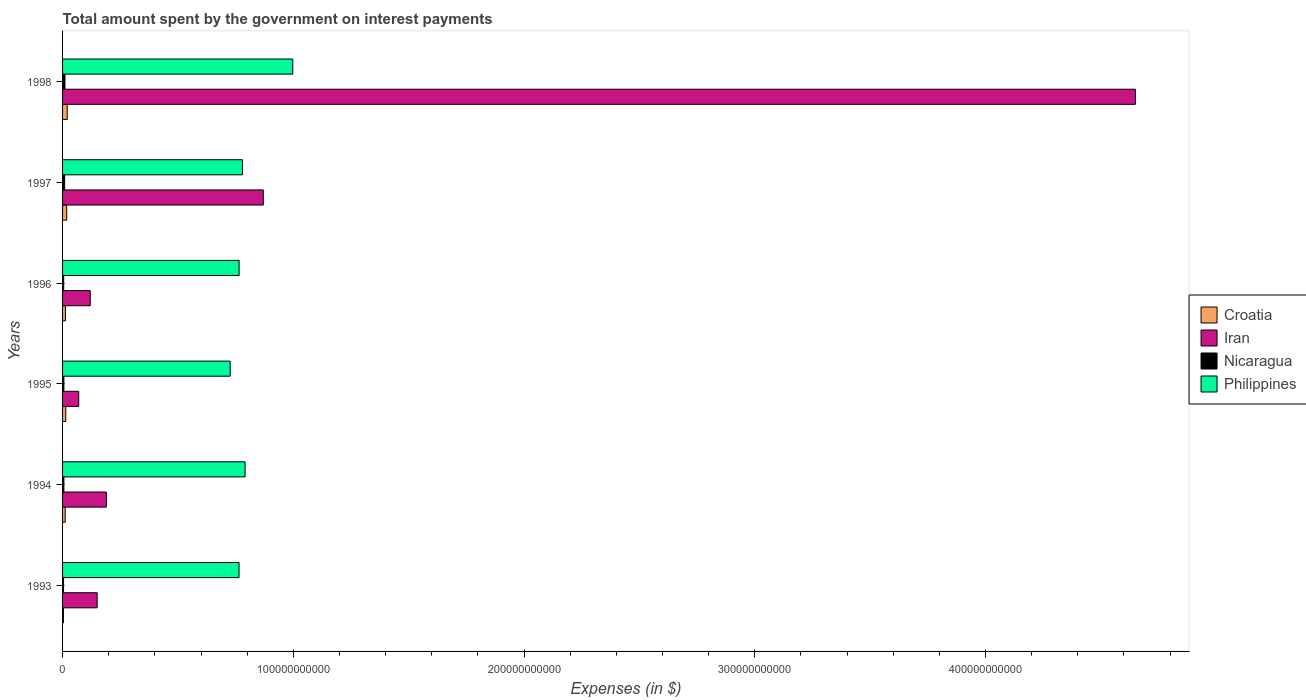How many different coloured bars are there?
Provide a short and direct response. 4. How many groups of bars are there?
Provide a succinct answer. 6. How many bars are there on the 5th tick from the top?
Offer a terse response. 4. How many bars are there on the 1st tick from the bottom?
Your response must be concise. 4. What is the label of the 6th group of bars from the top?
Your answer should be very brief. 1993. In how many cases, is the number of bars for a given year not equal to the number of legend labels?
Give a very brief answer. 0. What is the amount spent on interest payments by the government in Nicaragua in 1994?
Make the answer very short. 5.79e+08. Across all years, what is the maximum amount spent on interest payments by the government in Croatia?
Provide a succinct answer. 2.03e+09. Across all years, what is the minimum amount spent on interest payments by the government in Croatia?
Provide a short and direct response. 3.82e+08. In which year was the amount spent on interest payments by the government in Iran maximum?
Your answer should be very brief. 1998. In which year was the amount spent on interest payments by the government in Iran minimum?
Make the answer very short. 1995. What is the total amount spent on interest payments by the government in Iran in the graph?
Your answer should be very brief. 6.05e+11. What is the difference between the amount spent on interest payments by the government in Iran in 1995 and that in 1996?
Give a very brief answer. -5.00e+09. What is the difference between the amount spent on interest payments by the government in Croatia in 1996 and the amount spent on interest payments by the government in Iran in 1998?
Your answer should be very brief. -4.64e+11. What is the average amount spent on interest payments by the government in Philippines per year?
Your answer should be very brief. 8.04e+1. In the year 1994, what is the difference between the amount spent on interest payments by the government in Nicaragua and amount spent on interest payments by the government in Philippines?
Offer a terse response. -7.85e+1. What is the ratio of the amount spent on interest payments by the government in Croatia in 1994 to that in 1996?
Ensure brevity in your answer.  0.92. What is the difference between the highest and the second highest amount spent on interest payments by the government in Nicaragua?
Give a very brief answer. 1.47e+08. What is the difference between the highest and the lowest amount spent on interest payments by the government in Croatia?
Offer a terse response. 1.64e+09. Is the sum of the amount spent on interest payments by the government in Croatia in 1994 and 1997 greater than the maximum amount spent on interest payments by the government in Philippines across all years?
Offer a very short reply. No. Is it the case that in every year, the sum of the amount spent on interest payments by the government in Croatia and amount spent on interest payments by the government in Iran is greater than the sum of amount spent on interest payments by the government in Nicaragua and amount spent on interest payments by the government in Philippines?
Keep it short and to the point. No. What does the 2nd bar from the top in 1997 represents?
Your response must be concise. Nicaragua. What does the 1st bar from the bottom in 1993 represents?
Offer a very short reply. Croatia. Is it the case that in every year, the sum of the amount spent on interest payments by the government in Philippines and amount spent on interest payments by the government in Nicaragua is greater than the amount spent on interest payments by the government in Iran?
Your response must be concise. No. What is the difference between two consecutive major ticks on the X-axis?
Your answer should be very brief. 1.00e+11. Does the graph contain any zero values?
Offer a very short reply. No. How are the legend labels stacked?
Your response must be concise. Vertical. What is the title of the graph?
Ensure brevity in your answer.  Total amount spent by the government on interest payments. What is the label or title of the X-axis?
Give a very brief answer. Expenses (in $). What is the label or title of the Y-axis?
Your answer should be compact. Years. What is the Expenses (in $) of Croatia in 1993?
Offer a terse response. 3.82e+08. What is the Expenses (in $) of Iran in 1993?
Make the answer very short. 1.50e+1. What is the Expenses (in $) of Nicaragua in 1993?
Your answer should be compact. 4.27e+08. What is the Expenses (in $) in Philippines in 1993?
Your response must be concise. 7.65e+1. What is the Expenses (in $) in Croatia in 1994?
Your answer should be very brief. 1.14e+09. What is the Expenses (in $) of Iran in 1994?
Ensure brevity in your answer.  1.90e+1. What is the Expenses (in $) of Nicaragua in 1994?
Make the answer very short. 5.79e+08. What is the Expenses (in $) in Philippines in 1994?
Your answer should be very brief. 7.91e+1. What is the Expenses (in $) in Croatia in 1995?
Offer a terse response. 1.40e+09. What is the Expenses (in $) in Iran in 1995?
Offer a terse response. 7.00e+09. What is the Expenses (in $) of Nicaragua in 1995?
Offer a very short reply. 5.71e+08. What is the Expenses (in $) in Philippines in 1995?
Provide a short and direct response. 7.27e+1. What is the Expenses (in $) in Croatia in 1996?
Offer a terse response. 1.23e+09. What is the Expenses (in $) in Iran in 1996?
Offer a terse response. 1.20e+1. What is the Expenses (in $) of Nicaragua in 1996?
Keep it short and to the point. 4.96e+08. What is the Expenses (in $) of Philippines in 1996?
Your answer should be compact. 7.65e+1. What is the Expenses (in $) of Croatia in 1997?
Your answer should be compact. 1.79e+09. What is the Expenses (in $) in Iran in 1997?
Keep it short and to the point. 8.70e+1. What is the Expenses (in $) in Nicaragua in 1997?
Provide a short and direct response. 8.99e+08. What is the Expenses (in $) in Philippines in 1997?
Provide a succinct answer. 7.80e+1. What is the Expenses (in $) of Croatia in 1998?
Ensure brevity in your answer.  2.03e+09. What is the Expenses (in $) in Iran in 1998?
Ensure brevity in your answer.  4.65e+11. What is the Expenses (in $) in Nicaragua in 1998?
Make the answer very short. 1.05e+09. What is the Expenses (in $) of Philippines in 1998?
Offer a very short reply. 9.98e+1. Across all years, what is the maximum Expenses (in $) in Croatia?
Ensure brevity in your answer.  2.03e+09. Across all years, what is the maximum Expenses (in $) of Iran?
Provide a short and direct response. 4.65e+11. Across all years, what is the maximum Expenses (in $) of Nicaragua?
Your answer should be compact. 1.05e+09. Across all years, what is the maximum Expenses (in $) of Philippines?
Ensure brevity in your answer.  9.98e+1. Across all years, what is the minimum Expenses (in $) in Croatia?
Provide a succinct answer. 3.82e+08. Across all years, what is the minimum Expenses (in $) in Iran?
Provide a short and direct response. 7.00e+09. Across all years, what is the minimum Expenses (in $) of Nicaragua?
Offer a terse response. 4.27e+08. Across all years, what is the minimum Expenses (in $) in Philippines?
Provide a succinct answer. 7.27e+1. What is the total Expenses (in $) of Croatia in the graph?
Your answer should be very brief. 7.97e+09. What is the total Expenses (in $) of Iran in the graph?
Your answer should be very brief. 6.05e+11. What is the total Expenses (in $) in Nicaragua in the graph?
Your answer should be compact. 4.02e+09. What is the total Expenses (in $) in Philippines in the graph?
Your answer should be very brief. 4.83e+11. What is the difference between the Expenses (in $) of Croatia in 1993 and that in 1994?
Make the answer very short. -7.55e+08. What is the difference between the Expenses (in $) of Iran in 1993 and that in 1994?
Keep it short and to the point. -4.00e+09. What is the difference between the Expenses (in $) of Nicaragua in 1993 and that in 1994?
Give a very brief answer. -1.52e+08. What is the difference between the Expenses (in $) of Philippines in 1993 and that in 1994?
Your answer should be compact. -2.63e+09. What is the difference between the Expenses (in $) in Croatia in 1993 and that in 1995?
Provide a succinct answer. -1.02e+09. What is the difference between the Expenses (in $) in Iran in 1993 and that in 1995?
Offer a terse response. 8.00e+09. What is the difference between the Expenses (in $) in Nicaragua in 1993 and that in 1995?
Offer a terse response. -1.44e+08. What is the difference between the Expenses (in $) in Philippines in 1993 and that in 1995?
Your response must be concise. 3.83e+09. What is the difference between the Expenses (in $) of Croatia in 1993 and that in 1996?
Keep it short and to the point. -8.53e+08. What is the difference between the Expenses (in $) of Iran in 1993 and that in 1996?
Provide a short and direct response. 3.00e+09. What is the difference between the Expenses (in $) in Nicaragua in 1993 and that in 1996?
Your response must be concise. -6.94e+07. What is the difference between the Expenses (in $) in Philippines in 1993 and that in 1996?
Provide a succinct answer. -3.10e+07. What is the difference between the Expenses (in $) in Croatia in 1993 and that in 1997?
Give a very brief answer. -1.41e+09. What is the difference between the Expenses (in $) in Iran in 1993 and that in 1997?
Offer a terse response. -7.20e+1. What is the difference between the Expenses (in $) in Nicaragua in 1993 and that in 1997?
Your answer should be compact. -4.72e+08. What is the difference between the Expenses (in $) of Philippines in 1993 and that in 1997?
Your answer should be compact. -1.48e+09. What is the difference between the Expenses (in $) of Croatia in 1993 and that in 1998?
Ensure brevity in your answer.  -1.64e+09. What is the difference between the Expenses (in $) of Iran in 1993 and that in 1998?
Offer a terse response. -4.50e+11. What is the difference between the Expenses (in $) in Nicaragua in 1993 and that in 1998?
Provide a succinct answer. -6.19e+08. What is the difference between the Expenses (in $) in Philippines in 1993 and that in 1998?
Your answer should be very brief. -2.33e+1. What is the difference between the Expenses (in $) of Croatia in 1994 and that in 1995?
Provide a succinct answer. -2.63e+08. What is the difference between the Expenses (in $) in Iran in 1994 and that in 1995?
Keep it short and to the point. 1.20e+1. What is the difference between the Expenses (in $) in Nicaragua in 1994 and that in 1995?
Offer a very short reply. 8.12e+06. What is the difference between the Expenses (in $) of Philippines in 1994 and that in 1995?
Provide a succinct answer. 6.46e+09. What is the difference between the Expenses (in $) of Croatia in 1994 and that in 1996?
Provide a succinct answer. -9.75e+07. What is the difference between the Expenses (in $) of Iran in 1994 and that in 1996?
Your answer should be compact. 7.00e+09. What is the difference between the Expenses (in $) of Nicaragua in 1994 and that in 1996?
Give a very brief answer. 8.28e+07. What is the difference between the Expenses (in $) of Philippines in 1994 and that in 1996?
Your answer should be very brief. 2.60e+09. What is the difference between the Expenses (in $) in Croatia in 1994 and that in 1997?
Provide a succinct answer. -6.54e+08. What is the difference between the Expenses (in $) of Iran in 1994 and that in 1997?
Offer a terse response. -6.80e+1. What is the difference between the Expenses (in $) in Nicaragua in 1994 and that in 1997?
Give a very brief answer. -3.20e+08. What is the difference between the Expenses (in $) in Philippines in 1994 and that in 1997?
Your answer should be compact. 1.15e+09. What is the difference between the Expenses (in $) in Croatia in 1994 and that in 1998?
Offer a terse response. -8.89e+08. What is the difference between the Expenses (in $) in Iran in 1994 and that in 1998?
Make the answer very short. -4.46e+11. What is the difference between the Expenses (in $) of Nicaragua in 1994 and that in 1998?
Make the answer very short. -4.66e+08. What is the difference between the Expenses (in $) of Philippines in 1994 and that in 1998?
Give a very brief answer. -2.07e+1. What is the difference between the Expenses (in $) in Croatia in 1995 and that in 1996?
Your answer should be compact. 1.66e+08. What is the difference between the Expenses (in $) of Iran in 1995 and that in 1996?
Give a very brief answer. -5.00e+09. What is the difference between the Expenses (in $) of Nicaragua in 1995 and that in 1996?
Offer a terse response. 7.47e+07. What is the difference between the Expenses (in $) of Philippines in 1995 and that in 1996?
Offer a very short reply. -3.86e+09. What is the difference between the Expenses (in $) in Croatia in 1995 and that in 1997?
Your response must be concise. -3.91e+08. What is the difference between the Expenses (in $) in Iran in 1995 and that in 1997?
Ensure brevity in your answer.  -8.00e+1. What is the difference between the Expenses (in $) in Nicaragua in 1995 and that in 1997?
Your answer should be compact. -3.28e+08. What is the difference between the Expenses (in $) in Philippines in 1995 and that in 1997?
Your response must be concise. -5.31e+09. What is the difference between the Expenses (in $) of Croatia in 1995 and that in 1998?
Make the answer very short. -6.26e+08. What is the difference between the Expenses (in $) in Iran in 1995 and that in 1998?
Provide a succinct answer. -4.58e+11. What is the difference between the Expenses (in $) of Nicaragua in 1995 and that in 1998?
Give a very brief answer. -4.74e+08. What is the difference between the Expenses (in $) in Philippines in 1995 and that in 1998?
Provide a short and direct response. -2.71e+1. What is the difference between the Expenses (in $) of Croatia in 1996 and that in 1997?
Offer a terse response. -5.56e+08. What is the difference between the Expenses (in $) of Iran in 1996 and that in 1997?
Offer a very short reply. -7.50e+1. What is the difference between the Expenses (in $) in Nicaragua in 1996 and that in 1997?
Keep it short and to the point. -4.03e+08. What is the difference between the Expenses (in $) of Philippines in 1996 and that in 1997?
Keep it short and to the point. -1.45e+09. What is the difference between the Expenses (in $) in Croatia in 1996 and that in 1998?
Provide a succinct answer. -7.92e+08. What is the difference between the Expenses (in $) in Iran in 1996 and that in 1998?
Your answer should be compact. -4.53e+11. What is the difference between the Expenses (in $) in Nicaragua in 1996 and that in 1998?
Ensure brevity in your answer.  -5.49e+08. What is the difference between the Expenses (in $) of Philippines in 1996 and that in 1998?
Your answer should be very brief. -2.33e+1. What is the difference between the Expenses (in $) of Croatia in 1997 and that in 1998?
Your answer should be very brief. -2.35e+08. What is the difference between the Expenses (in $) of Iran in 1997 and that in 1998?
Provide a short and direct response. -3.78e+11. What is the difference between the Expenses (in $) of Nicaragua in 1997 and that in 1998?
Give a very brief answer. -1.47e+08. What is the difference between the Expenses (in $) in Philippines in 1997 and that in 1998?
Provide a short and direct response. -2.18e+1. What is the difference between the Expenses (in $) of Croatia in 1993 and the Expenses (in $) of Iran in 1994?
Keep it short and to the point. -1.86e+1. What is the difference between the Expenses (in $) of Croatia in 1993 and the Expenses (in $) of Nicaragua in 1994?
Keep it short and to the point. -1.97e+08. What is the difference between the Expenses (in $) in Croatia in 1993 and the Expenses (in $) in Philippines in 1994?
Provide a short and direct response. -7.87e+1. What is the difference between the Expenses (in $) in Iran in 1993 and the Expenses (in $) in Nicaragua in 1994?
Your response must be concise. 1.44e+1. What is the difference between the Expenses (in $) of Iran in 1993 and the Expenses (in $) of Philippines in 1994?
Provide a succinct answer. -6.41e+1. What is the difference between the Expenses (in $) of Nicaragua in 1993 and the Expenses (in $) of Philippines in 1994?
Keep it short and to the point. -7.87e+1. What is the difference between the Expenses (in $) in Croatia in 1993 and the Expenses (in $) in Iran in 1995?
Make the answer very short. -6.62e+09. What is the difference between the Expenses (in $) in Croatia in 1993 and the Expenses (in $) in Nicaragua in 1995?
Offer a very short reply. -1.89e+08. What is the difference between the Expenses (in $) of Croatia in 1993 and the Expenses (in $) of Philippines in 1995?
Provide a short and direct response. -7.23e+1. What is the difference between the Expenses (in $) of Iran in 1993 and the Expenses (in $) of Nicaragua in 1995?
Offer a very short reply. 1.44e+1. What is the difference between the Expenses (in $) in Iran in 1993 and the Expenses (in $) in Philippines in 1995?
Your answer should be very brief. -5.77e+1. What is the difference between the Expenses (in $) of Nicaragua in 1993 and the Expenses (in $) of Philippines in 1995?
Your response must be concise. -7.22e+1. What is the difference between the Expenses (in $) of Croatia in 1993 and the Expenses (in $) of Iran in 1996?
Provide a succinct answer. -1.16e+1. What is the difference between the Expenses (in $) in Croatia in 1993 and the Expenses (in $) in Nicaragua in 1996?
Offer a very short reply. -1.14e+08. What is the difference between the Expenses (in $) in Croatia in 1993 and the Expenses (in $) in Philippines in 1996?
Your answer should be compact. -7.61e+1. What is the difference between the Expenses (in $) in Iran in 1993 and the Expenses (in $) in Nicaragua in 1996?
Provide a succinct answer. 1.45e+1. What is the difference between the Expenses (in $) in Iran in 1993 and the Expenses (in $) in Philippines in 1996?
Provide a short and direct response. -6.15e+1. What is the difference between the Expenses (in $) of Nicaragua in 1993 and the Expenses (in $) of Philippines in 1996?
Ensure brevity in your answer.  -7.61e+1. What is the difference between the Expenses (in $) in Croatia in 1993 and the Expenses (in $) in Iran in 1997?
Your response must be concise. -8.66e+1. What is the difference between the Expenses (in $) of Croatia in 1993 and the Expenses (in $) of Nicaragua in 1997?
Provide a succinct answer. -5.17e+08. What is the difference between the Expenses (in $) in Croatia in 1993 and the Expenses (in $) in Philippines in 1997?
Your answer should be compact. -7.76e+1. What is the difference between the Expenses (in $) of Iran in 1993 and the Expenses (in $) of Nicaragua in 1997?
Offer a very short reply. 1.41e+1. What is the difference between the Expenses (in $) in Iran in 1993 and the Expenses (in $) in Philippines in 1997?
Provide a succinct answer. -6.30e+1. What is the difference between the Expenses (in $) of Nicaragua in 1993 and the Expenses (in $) of Philippines in 1997?
Offer a very short reply. -7.75e+1. What is the difference between the Expenses (in $) in Croatia in 1993 and the Expenses (in $) in Iran in 1998?
Your answer should be very brief. -4.65e+11. What is the difference between the Expenses (in $) of Croatia in 1993 and the Expenses (in $) of Nicaragua in 1998?
Keep it short and to the point. -6.63e+08. What is the difference between the Expenses (in $) in Croatia in 1993 and the Expenses (in $) in Philippines in 1998?
Your answer should be very brief. -9.94e+1. What is the difference between the Expenses (in $) in Iran in 1993 and the Expenses (in $) in Nicaragua in 1998?
Give a very brief answer. 1.40e+1. What is the difference between the Expenses (in $) in Iran in 1993 and the Expenses (in $) in Philippines in 1998?
Ensure brevity in your answer.  -8.48e+1. What is the difference between the Expenses (in $) of Nicaragua in 1993 and the Expenses (in $) of Philippines in 1998?
Your answer should be compact. -9.94e+1. What is the difference between the Expenses (in $) of Croatia in 1994 and the Expenses (in $) of Iran in 1995?
Ensure brevity in your answer.  -5.86e+09. What is the difference between the Expenses (in $) of Croatia in 1994 and the Expenses (in $) of Nicaragua in 1995?
Your answer should be compact. 5.66e+08. What is the difference between the Expenses (in $) of Croatia in 1994 and the Expenses (in $) of Philippines in 1995?
Your response must be concise. -7.15e+1. What is the difference between the Expenses (in $) of Iran in 1994 and the Expenses (in $) of Nicaragua in 1995?
Provide a succinct answer. 1.84e+1. What is the difference between the Expenses (in $) of Iran in 1994 and the Expenses (in $) of Philippines in 1995?
Give a very brief answer. -5.37e+1. What is the difference between the Expenses (in $) of Nicaragua in 1994 and the Expenses (in $) of Philippines in 1995?
Provide a short and direct response. -7.21e+1. What is the difference between the Expenses (in $) of Croatia in 1994 and the Expenses (in $) of Iran in 1996?
Ensure brevity in your answer.  -1.09e+1. What is the difference between the Expenses (in $) in Croatia in 1994 and the Expenses (in $) in Nicaragua in 1996?
Your response must be concise. 6.41e+08. What is the difference between the Expenses (in $) of Croatia in 1994 and the Expenses (in $) of Philippines in 1996?
Your answer should be very brief. -7.54e+1. What is the difference between the Expenses (in $) in Iran in 1994 and the Expenses (in $) in Nicaragua in 1996?
Offer a very short reply. 1.85e+1. What is the difference between the Expenses (in $) of Iran in 1994 and the Expenses (in $) of Philippines in 1996?
Your answer should be very brief. -5.75e+1. What is the difference between the Expenses (in $) of Nicaragua in 1994 and the Expenses (in $) of Philippines in 1996?
Give a very brief answer. -7.59e+1. What is the difference between the Expenses (in $) in Croatia in 1994 and the Expenses (in $) in Iran in 1997?
Your response must be concise. -8.59e+1. What is the difference between the Expenses (in $) in Croatia in 1994 and the Expenses (in $) in Nicaragua in 1997?
Your answer should be compact. 2.38e+08. What is the difference between the Expenses (in $) in Croatia in 1994 and the Expenses (in $) in Philippines in 1997?
Your response must be concise. -7.68e+1. What is the difference between the Expenses (in $) in Iran in 1994 and the Expenses (in $) in Nicaragua in 1997?
Keep it short and to the point. 1.81e+1. What is the difference between the Expenses (in $) in Iran in 1994 and the Expenses (in $) in Philippines in 1997?
Give a very brief answer. -5.90e+1. What is the difference between the Expenses (in $) in Nicaragua in 1994 and the Expenses (in $) in Philippines in 1997?
Offer a terse response. -7.74e+1. What is the difference between the Expenses (in $) in Croatia in 1994 and the Expenses (in $) in Iran in 1998?
Your response must be concise. -4.64e+11. What is the difference between the Expenses (in $) of Croatia in 1994 and the Expenses (in $) of Nicaragua in 1998?
Your answer should be very brief. 9.17e+07. What is the difference between the Expenses (in $) in Croatia in 1994 and the Expenses (in $) in Philippines in 1998?
Your answer should be compact. -9.87e+1. What is the difference between the Expenses (in $) of Iran in 1994 and the Expenses (in $) of Nicaragua in 1998?
Make the answer very short. 1.80e+1. What is the difference between the Expenses (in $) in Iran in 1994 and the Expenses (in $) in Philippines in 1998?
Provide a succinct answer. -8.08e+1. What is the difference between the Expenses (in $) of Nicaragua in 1994 and the Expenses (in $) of Philippines in 1998?
Your response must be concise. -9.92e+1. What is the difference between the Expenses (in $) in Croatia in 1995 and the Expenses (in $) in Iran in 1996?
Offer a terse response. -1.06e+1. What is the difference between the Expenses (in $) in Croatia in 1995 and the Expenses (in $) in Nicaragua in 1996?
Offer a terse response. 9.04e+08. What is the difference between the Expenses (in $) in Croatia in 1995 and the Expenses (in $) in Philippines in 1996?
Give a very brief answer. -7.51e+1. What is the difference between the Expenses (in $) of Iran in 1995 and the Expenses (in $) of Nicaragua in 1996?
Your answer should be very brief. 6.50e+09. What is the difference between the Expenses (in $) in Iran in 1995 and the Expenses (in $) in Philippines in 1996?
Provide a succinct answer. -6.95e+1. What is the difference between the Expenses (in $) of Nicaragua in 1995 and the Expenses (in $) of Philippines in 1996?
Your answer should be compact. -7.60e+1. What is the difference between the Expenses (in $) in Croatia in 1995 and the Expenses (in $) in Iran in 1997?
Ensure brevity in your answer.  -8.56e+1. What is the difference between the Expenses (in $) of Croatia in 1995 and the Expenses (in $) of Nicaragua in 1997?
Ensure brevity in your answer.  5.01e+08. What is the difference between the Expenses (in $) in Croatia in 1995 and the Expenses (in $) in Philippines in 1997?
Your answer should be very brief. -7.66e+1. What is the difference between the Expenses (in $) of Iran in 1995 and the Expenses (in $) of Nicaragua in 1997?
Offer a very short reply. 6.10e+09. What is the difference between the Expenses (in $) in Iran in 1995 and the Expenses (in $) in Philippines in 1997?
Provide a succinct answer. -7.10e+1. What is the difference between the Expenses (in $) in Nicaragua in 1995 and the Expenses (in $) in Philippines in 1997?
Make the answer very short. -7.74e+1. What is the difference between the Expenses (in $) in Croatia in 1995 and the Expenses (in $) in Iran in 1998?
Give a very brief answer. -4.64e+11. What is the difference between the Expenses (in $) of Croatia in 1995 and the Expenses (in $) of Nicaragua in 1998?
Give a very brief answer. 3.55e+08. What is the difference between the Expenses (in $) of Croatia in 1995 and the Expenses (in $) of Philippines in 1998?
Offer a terse response. -9.84e+1. What is the difference between the Expenses (in $) of Iran in 1995 and the Expenses (in $) of Nicaragua in 1998?
Give a very brief answer. 5.95e+09. What is the difference between the Expenses (in $) of Iran in 1995 and the Expenses (in $) of Philippines in 1998?
Make the answer very short. -9.28e+1. What is the difference between the Expenses (in $) in Nicaragua in 1995 and the Expenses (in $) in Philippines in 1998?
Offer a terse response. -9.92e+1. What is the difference between the Expenses (in $) of Croatia in 1996 and the Expenses (in $) of Iran in 1997?
Your answer should be very brief. -8.58e+1. What is the difference between the Expenses (in $) in Croatia in 1996 and the Expenses (in $) in Nicaragua in 1997?
Ensure brevity in your answer.  3.36e+08. What is the difference between the Expenses (in $) of Croatia in 1996 and the Expenses (in $) of Philippines in 1997?
Make the answer very short. -7.67e+1. What is the difference between the Expenses (in $) of Iran in 1996 and the Expenses (in $) of Nicaragua in 1997?
Your answer should be very brief. 1.11e+1. What is the difference between the Expenses (in $) of Iran in 1996 and the Expenses (in $) of Philippines in 1997?
Your response must be concise. -6.60e+1. What is the difference between the Expenses (in $) in Nicaragua in 1996 and the Expenses (in $) in Philippines in 1997?
Keep it short and to the point. -7.75e+1. What is the difference between the Expenses (in $) in Croatia in 1996 and the Expenses (in $) in Iran in 1998?
Ensure brevity in your answer.  -4.64e+11. What is the difference between the Expenses (in $) in Croatia in 1996 and the Expenses (in $) in Nicaragua in 1998?
Give a very brief answer. 1.89e+08. What is the difference between the Expenses (in $) in Croatia in 1996 and the Expenses (in $) in Philippines in 1998?
Keep it short and to the point. -9.86e+1. What is the difference between the Expenses (in $) in Iran in 1996 and the Expenses (in $) in Nicaragua in 1998?
Ensure brevity in your answer.  1.10e+1. What is the difference between the Expenses (in $) in Iran in 1996 and the Expenses (in $) in Philippines in 1998?
Offer a very short reply. -8.78e+1. What is the difference between the Expenses (in $) of Nicaragua in 1996 and the Expenses (in $) of Philippines in 1998?
Ensure brevity in your answer.  -9.93e+1. What is the difference between the Expenses (in $) of Croatia in 1997 and the Expenses (in $) of Iran in 1998?
Offer a very short reply. -4.63e+11. What is the difference between the Expenses (in $) of Croatia in 1997 and the Expenses (in $) of Nicaragua in 1998?
Make the answer very short. 7.46e+08. What is the difference between the Expenses (in $) in Croatia in 1997 and the Expenses (in $) in Philippines in 1998?
Ensure brevity in your answer.  -9.80e+1. What is the difference between the Expenses (in $) of Iran in 1997 and the Expenses (in $) of Nicaragua in 1998?
Offer a terse response. 8.60e+1. What is the difference between the Expenses (in $) in Iran in 1997 and the Expenses (in $) in Philippines in 1998?
Your response must be concise. -1.28e+1. What is the difference between the Expenses (in $) in Nicaragua in 1997 and the Expenses (in $) in Philippines in 1998?
Your answer should be very brief. -9.89e+1. What is the average Expenses (in $) in Croatia per year?
Provide a short and direct response. 1.33e+09. What is the average Expenses (in $) in Iran per year?
Give a very brief answer. 1.01e+11. What is the average Expenses (in $) of Nicaragua per year?
Ensure brevity in your answer.  6.69e+08. What is the average Expenses (in $) of Philippines per year?
Offer a very short reply. 8.04e+1. In the year 1993, what is the difference between the Expenses (in $) in Croatia and Expenses (in $) in Iran?
Offer a very short reply. -1.46e+1. In the year 1993, what is the difference between the Expenses (in $) of Croatia and Expenses (in $) of Nicaragua?
Offer a very short reply. -4.49e+07. In the year 1993, what is the difference between the Expenses (in $) of Croatia and Expenses (in $) of Philippines?
Give a very brief answer. -7.61e+1. In the year 1993, what is the difference between the Expenses (in $) of Iran and Expenses (in $) of Nicaragua?
Your answer should be very brief. 1.46e+1. In the year 1993, what is the difference between the Expenses (in $) of Iran and Expenses (in $) of Philippines?
Provide a short and direct response. -6.15e+1. In the year 1993, what is the difference between the Expenses (in $) in Nicaragua and Expenses (in $) in Philippines?
Keep it short and to the point. -7.61e+1. In the year 1994, what is the difference between the Expenses (in $) of Croatia and Expenses (in $) of Iran?
Provide a short and direct response. -1.79e+1. In the year 1994, what is the difference between the Expenses (in $) of Croatia and Expenses (in $) of Nicaragua?
Offer a very short reply. 5.58e+08. In the year 1994, what is the difference between the Expenses (in $) of Croatia and Expenses (in $) of Philippines?
Provide a succinct answer. -7.80e+1. In the year 1994, what is the difference between the Expenses (in $) of Iran and Expenses (in $) of Nicaragua?
Make the answer very short. 1.84e+1. In the year 1994, what is the difference between the Expenses (in $) in Iran and Expenses (in $) in Philippines?
Your answer should be compact. -6.01e+1. In the year 1994, what is the difference between the Expenses (in $) of Nicaragua and Expenses (in $) of Philippines?
Your answer should be compact. -7.85e+1. In the year 1995, what is the difference between the Expenses (in $) in Croatia and Expenses (in $) in Iran?
Your response must be concise. -5.60e+09. In the year 1995, what is the difference between the Expenses (in $) in Croatia and Expenses (in $) in Nicaragua?
Your answer should be very brief. 8.29e+08. In the year 1995, what is the difference between the Expenses (in $) of Croatia and Expenses (in $) of Philippines?
Ensure brevity in your answer.  -7.13e+1. In the year 1995, what is the difference between the Expenses (in $) of Iran and Expenses (in $) of Nicaragua?
Your answer should be very brief. 6.43e+09. In the year 1995, what is the difference between the Expenses (in $) of Iran and Expenses (in $) of Philippines?
Your answer should be compact. -6.57e+1. In the year 1995, what is the difference between the Expenses (in $) of Nicaragua and Expenses (in $) of Philippines?
Offer a very short reply. -7.21e+1. In the year 1996, what is the difference between the Expenses (in $) of Croatia and Expenses (in $) of Iran?
Your answer should be compact. -1.08e+1. In the year 1996, what is the difference between the Expenses (in $) of Croatia and Expenses (in $) of Nicaragua?
Offer a very short reply. 7.38e+08. In the year 1996, what is the difference between the Expenses (in $) of Croatia and Expenses (in $) of Philippines?
Your answer should be very brief. -7.53e+1. In the year 1996, what is the difference between the Expenses (in $) in Iran and Expenses (in $) in Nicaragua?
Provide a succinct answer. 1.15e+1. In the year 1996, what is the difference between the Expenses (in $) of Iran and Expenses (in $) of Philippines?
Offer a very short reply. -6.45e+1. In the year 1996, what is the difference between the Expenses (in $) in Nicaragua and Expenses (in $) in Philippines?
Offer a very short reply. -7.60e+1. In the year 1997, what is the difference between the Expenses (in $) in Croatia and Expenses (in $) in Iran?
Offer a very short reply. -8.52e+1. In the year 1997, what is the difference between the Expenses (in $) of Croatia and Expenses (in $) of Nicaragua?
Your answer should be compact. 8.92e+08. In the year 1997, what is the difference between the Expenses (in $) in Croatia and Expenses (in $) in Philippines?
Provide a succinct answer. -7.62e+1. In the year 1997, what is the difference between the Expenses (in $) in Iran and Expenses (in $) in Nicaragua?
Provide a short and direct response. 8.61e+1. In the year 1997, what is the difference between the Expenses (in $) in Iran and Expenses (in $) in Philippines?
Make the answer very short. 9.03e+09. In the year 1997, what is the difference between the Expenses (in $) of Nicaragua and Expenses (in $) of Philippines?
Your response must be concise. -7.71e+1. In the year 1998, what is the difference between the Expenses (in $) of Croatia and Expenses (in $) of Iran?
Make the answer very short. -4.63e+11. In the year 1998, what is the difference between the Expenses (in $) in Croatia and Expenses (in $) in Nicaragua?
Provide a succinct answer. 9.81e+08. In the year 1998, what is the difference between the Expenses (in $) in Croatia and Expenses (in $) in Philippines?
Keep it short and to the point. -9.78e+1. In the year 1998, what is the difference between the Expenses (in $) in Iran and Expenses (in $) in Nicaragua?
Give a very brief answer. 4.64e+11. In the year 1998, what is the difference between the Expenses (in $) of Iran and Expenses (in $) of Philippines?
Make the answer very short. 3.65e+11. In the year 1998, what is the difference between the Expenses (in $) of Nicaragua and Expenses (in $) of Philippines?
Your answer should be compact. -9.87e+1. What is the ratio of the Expenses (in $) of Croatia in 1993 to that in 1994?
Your response must be concise. 0.34. What is the ratio of the Expenses (in $) in Iran in 1993 to that in 1994?
Your answer should be compact. 0.79. What is the ratio of the Expenses (in $) of Nicaragua in 1993 to that in 1994?
Make the answer very short. 0.74. What is the ratio of the Expenses (in $) of Philippines in 1993 to that in 1994?
Offer a terse response. 0.97. What is the ratio of the Expenses (in $) in Croatia in 1993 to that in 1995?
Your answer should be very brief. 0.27. What is the ratio of the Expenses (in $) in Iran in 1993 to that in 1995?
Your answer should be very brief. 2.14. What is the ratio of the Expenses (in $) in Nicaragua in 1993 to that in 1995?
Your answer should be compact. 0.75. What is the ratio of the Expenses (in $) in Philippines in 1993 to that in 1995?
Make the answer very short. 1.05. What is the ratio of the Expenses (in $) of Croatia in 1993 to that in 1996?
Your answer should be very brief. 0.31. What is the ratio of the Expenses (in $) in Nicaragua in 1993 to that in 1996?
Keep it short and to the point. 0.86. What is the ratio of the Expenses (in $) of Philippines in 1993 to that in 1996?
Your answer should be compact. 1. What is the ratio of the Expenses (in $) in Croatia in 1993 to that in 1997?
Provide a short and direct response. 0.21. What is the ratio of the Expenses (in $) in Iran in 1993 to that in 1997?
Your answer should be compact. 0.17. What is the ratio of the Expenses (in $) in Nicaragua in 1993 to that in 1997?
Ensure brevity in your answer.  0.47. What is the ratio of the Expenses (in $) of Philippines in 1993 to that in 1997?
Provide a succinct answer. 0.98. What is the ratio of the Expenses (in $) in Croatia in 1993 to that in 1998?
Offer a terse response. 0.19. What is the ratio of the Expenses (in $) of Iran in 1993 to that in 1998?
Ensure brevity in your answer.  0.03. What is the ratio of the Expenses (in $) in Nicaragua in 1993 to that in 1998?
Give a very brief answer. 0.41. What is the ratio of the Expenses (in $) in Philippines in 1993 to that in 1998?
Provide a short and direct response. 0.77. What is the ratio of the Expenses (in $) in Croatia in 1994 to that in 1995?
Keep it short and to the point. 0.81. What is the ratio of the Expenses (in $) of Iran in 1994 to that in 1995?
Your answer should be very brief. 2.71. What is the ratio of the Expenses (in $) of Nicaragua in 1994 to that in 1995?
Offer a terse response. 1.01. What is the ratio of the Expenses (in $) of Philippines in 1994 to that in 1995?
Ensure brevity in your answer.  1.09. What is the ratio of the Expenses (in $) in Croatia in 1994 to that in 1996?
Your response must be concise. 0.92. What is the ratio of the Expenses (in $) in Iran in 1994 to that in 1996?
Your answer should be compact. 1.58. What is the ratio of the Expenses (in $) of Nicaragua in 1994 to that in 1996?
Your response must be concise. 1.17. What is the ratio of the Expenses (in $) of Philippines in 1994 to that in 1996?
Your answer should be very brief. 1.03. What is the ratio of the Expenses (in $) of Croatia in 1994 to that in 1997?
Offer a terse response. 0.63. What is the ratio of the Expenses (in $) of Iran in 1994 to that in 1997?
Give a very brief answer. 0.22. What is the ratio of the Expenses (in $) of Nicaragua in 1994 to that in 1997?
Provide a succinct answer. 0.64. What is the ratio of the Expenses (in $) of Philippines in 1994 to that in 1997?
Provide a short and direct response. 1.01. What is the ratio of the Expenses (in $) in Croatia in 1994 to that in 1998?
Your answer should be very brief. 0.56. What is the ratio of the Expenses (in $) in Iran in 1994 to that in 1998?
Make the answer very short. 0.04. What is the ratio of the Expenses (in $) in Nicaragua in 1994 to that in 1998?
Your response must be concise. 0.55. What is the ratio of the Expenses (in $) in Philippines in 1994 to that in 1998?
Offer a terse response. 0.79. What is the ratio of the Expenses (in $) in Croatia in 1995 to that in 1996?
Your answer should be very brief. 1.13. What is the ratio of the Expenses (in $) of Iran in 1995 to that in 1996?
Give a very brief answer. 0.58. What is the ratio of the Expenses (in $) of Nicaragua in 1995 to that in 1996?
Your answer should be compact. 1.15. What is the ratio of the Expenses (in $) in Philippines in 1995 to that in 1996?
Offer a terse response. 0.95. What is the ratio of the Expenses (in $) in Croatia in 1995 to that in 1997?
Offer a very short reply. 0.78. What is the ratio of the Expenses (in $) in Iran in 1995 to that in 1997?
Keep it short and to the point. 0.08. What is the ratio of the Expenses (in $) of Nicaragua in 1995 to that in 1997?
Give a very brief answer. 0.64. What is the ratio of the Expenses (in $) of Philippines in 1995 to that in 1997?
Keep it short and to the point. 0.93. What is the ratio of the Expenses (in $) in Croatia in 1995 to that in 1998?
Give a very brief answer. 0.69. What is the ratio of the Expenses (in $) of Iran in 1995 to that in 1998?
Provide a succinct answer. 0.02. What is the ratio of the Expenses (in $) in Nicaragua in 1995 to that in 1998?
Ensure brevity in your answer.  0.55. What is the ratio of the Expenses (in $) of Philippines in 1995 to that in 1998?
Ensure brevity in your answer.  0.73. What is the ratio of the Expenses (in $) in Croatia in 1996 to that in 1997?
Make the answer very short. 0.69. What is the ratio of the Expenses (in $) in Iran in 1996 to that in 1997?
Provide a short and direct response. 0.14. What is the ratio of the Expenses (in $) of Nicaragua in 1996 to that in 1997?
Your answer should be compact. 0.55. What is the ratio of the Expenses (in $) in Philippines in 1996 to that in 1997?
Ensure brevity in your answer.  0.98. What is the ratio of the Expenses (in $) in Croatia in 1996 to that in 1998?
Your response must be concise. 0.61. What is the ratio of the Expenses (in $) of Iran in 1996 to that in 1998?
Provide a succinct answer. 0.03. What is the ratio of the Expenses (in $) in Nicaragua in 1996 to that in 1998?
Provide a short and direct response. 0.47. What is the ratio of the Expenses (in $) in Philippines in 1996 to that in 1998?
Your answer should be very brief. 0.77. What is the ratio of the Expenses (in $) in Croatia in 1997 to that in 1998?
Make the answer very short. 0.88. What is the ratio of the Expenses (in $) of Iran in 1997 to that in 1998?
Ensure brevity in your answer.  0.19. What is the ratio of the Expenses (in $) in Nicaragua in 1997 to that in 1998?
Give a very brief answer. 0.86. What is the ratio of the Expenses (in $) in Philippines in 1997 to that in 1998?
Your answer should be compact. 0.78. What is the difference between the highest and the second highest Expenses (in $) of Croatia?
Your answer should be compact. 2.35e+08. What is the difference between the highest and the second highest Expenses (in $) in Iran?
Provide a succinct answer. 3.78e+11. What is the difference between the highest and the second highest Expenses (in $) of Nicaragua?
Keep it short and to the point. 1.47e+08. What is the difference between the highest and the second highest Expenses (in $) in Philippines?
Ensure brevity in your answer.  2.07e+1. What is the difference between the highest and the lowest Expenses (in $) of Croatia?
Provide a succinct answer. 1.64e+09. What is the difference between the highest and the lowest Expenses (in $) in Iran?
Provide a short and direct response. 4.58e+11. What is the difference between the highest and the lowest Expenses (in $) of Nicaragua?
Keep it short and to the point. 6.19e+08. What is the difference between the highest and the lowest Expenses (in $) of Philippines?
Your answer should be very brief. 2.71e+1. 